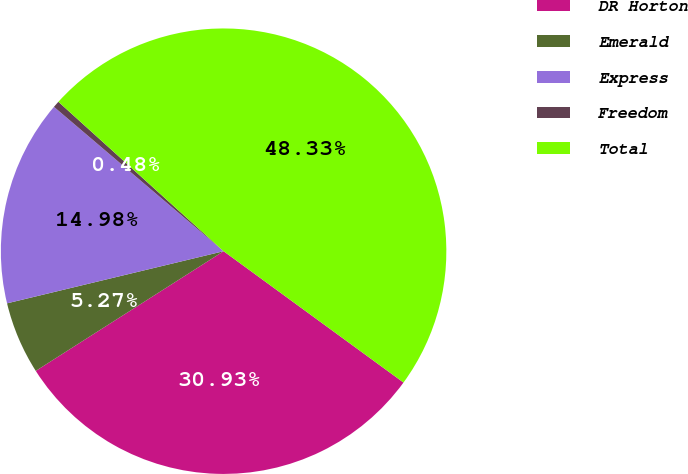<chart> <loc_0><loc_0><loc_500><loc_500><pie_chart><fcel>DR Horton<fcel>Emerald<fcel>Express<fcel>Freedom<fcel>Total<nl><fcel>30.93%<fcel>5.27%<fcel>14.98%<fcel>0.48%<fcel>48.33%<nl></chart> 